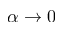<formula> <loc_0><loc_0><loc_500><loc_500>\alpha \to 0</formula> 